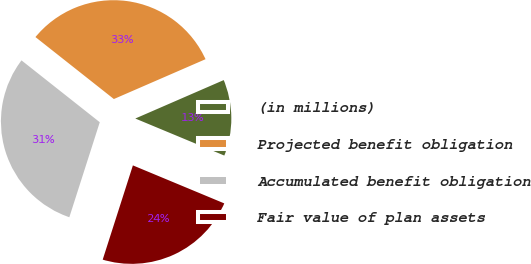Convert chart. <chart><loc_0><loc_0><loc_500><loc_500><pie_chart><fcel>(in millions)<fcel>Projected benefit obligation<fcel>Accumulated benefit obligation<fcel>Fair value of plan assets<nl><fcel>12.8%<fcel>32.83%<fcel>30.71%<fcel>23.66%<nl></chart> 